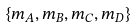<formula> <loc_0><loc_0><loc_500><loc_500>\left \{ m _ { A } , m _ { B } , m _ { C } , m _ { D } \right \}</formula> 